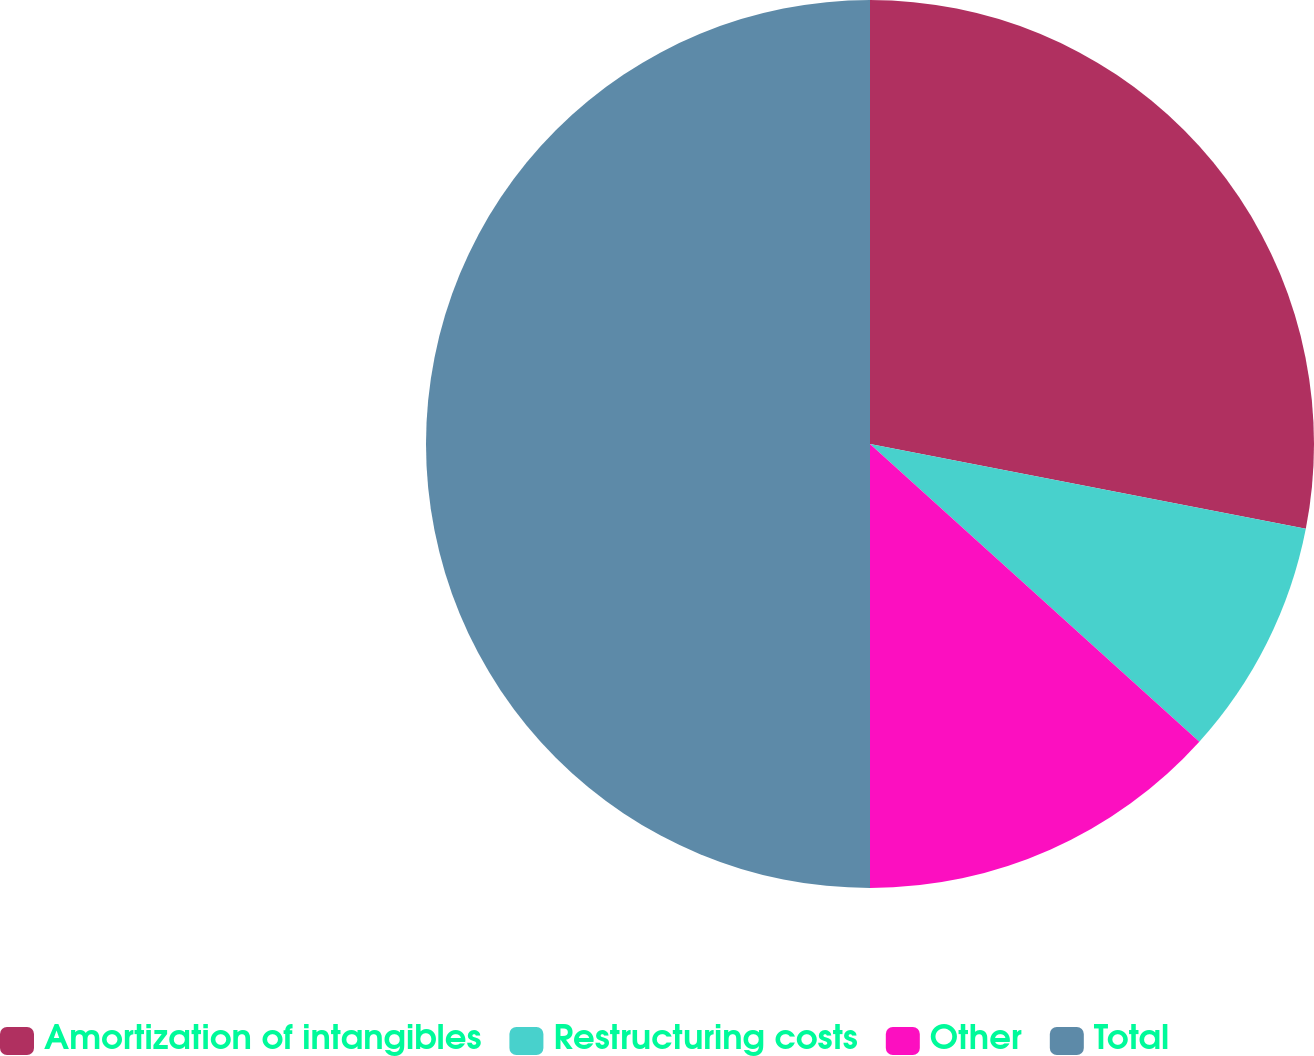Convert chart. <chart><loc_0><loc_0><loc_500><loc_500><pie_chart><fcel>Amortization of intangibles<fcel>Restructuring costs<fcel>Other<fcel>Total<nl><fcel>28.06%<fcel>8.64%<fcel>13.3%<fcel>50.0%<nl></chart> 